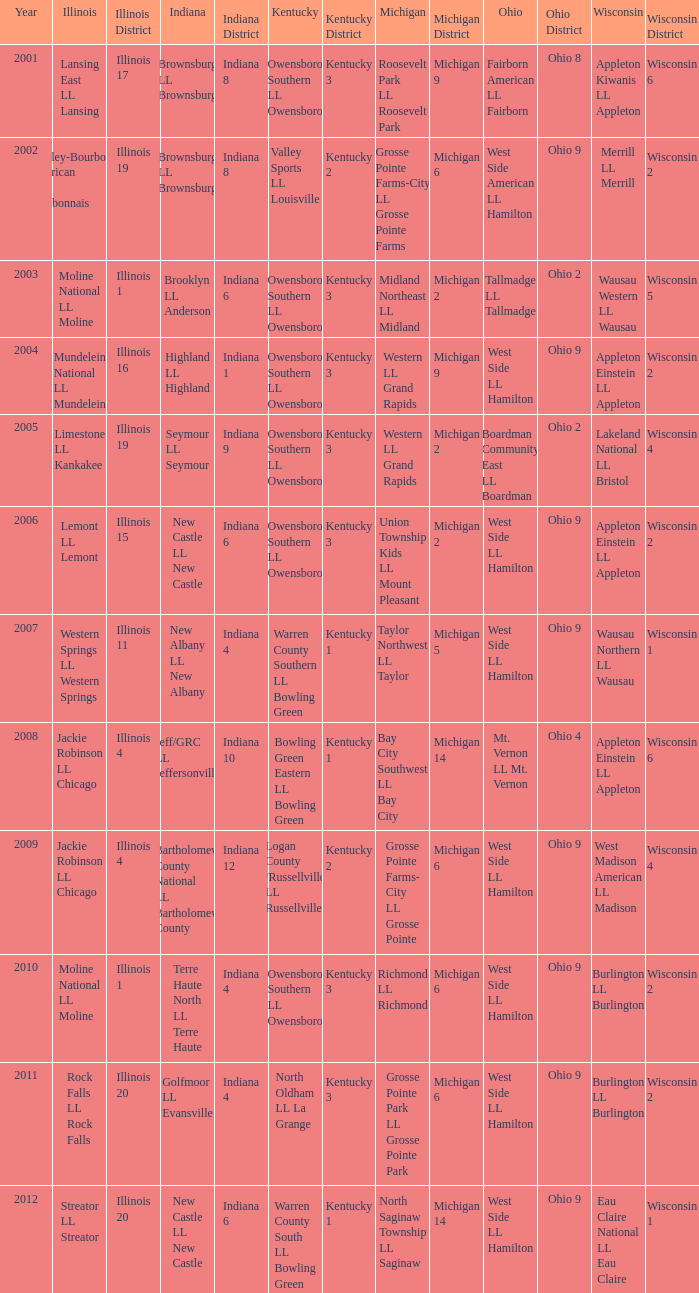What was the little league team from Indiana when the little league team from Michigan was Midland Northeast LL Midland? Brooklyn LL Anderson. 